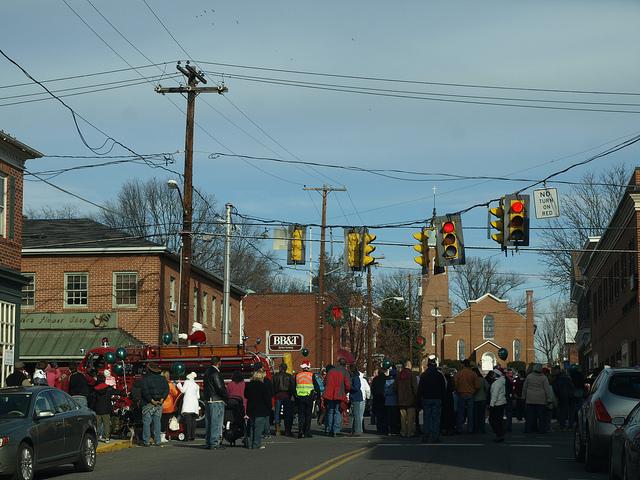How many lantern's are red?
Write a very short answer. 2. Who is the man standing next to the truck?
Write a very short answer. Not possible. Are all these people going to church?
Give a very brief answer. No. What light is lit on the traffic light?
Concise answer only. Red. How many people can you see?
Give a very brief answer. Many. How many street lights can be seen?
Be succinct. 7. What color is the van?
Be succinct. Silver. How many people are there?
Short answer required. Lot. How many people are wearing safety jackets?
Keep it brief. 1. Is this photo taken in the desert?
Answer briefly. No. Are there any cars on the street?
Be succinct. Yes. How many people appear in this photo?
Give a very brief answer. 28. Is this a palm tree?
Short answer required. No. Is the light on the left side green?
Be succinct. No. What color is the vest of the traffic signaler?
Be succinct. Orange. How many lights are hanging freely?
Concise answer only. 5. Is the color black and white?
Keep it brief. No. What color is the traffic light signaling?
Keep it brief. Red. How many cars are there?
Concise answer only. 3. Is it daylight?
Concise answer only. Yes. Is this picture taken with a fisheye lens?
Write a very short answer. No. Are there any people crossing the street?
Give a very brief answer. Yes. 